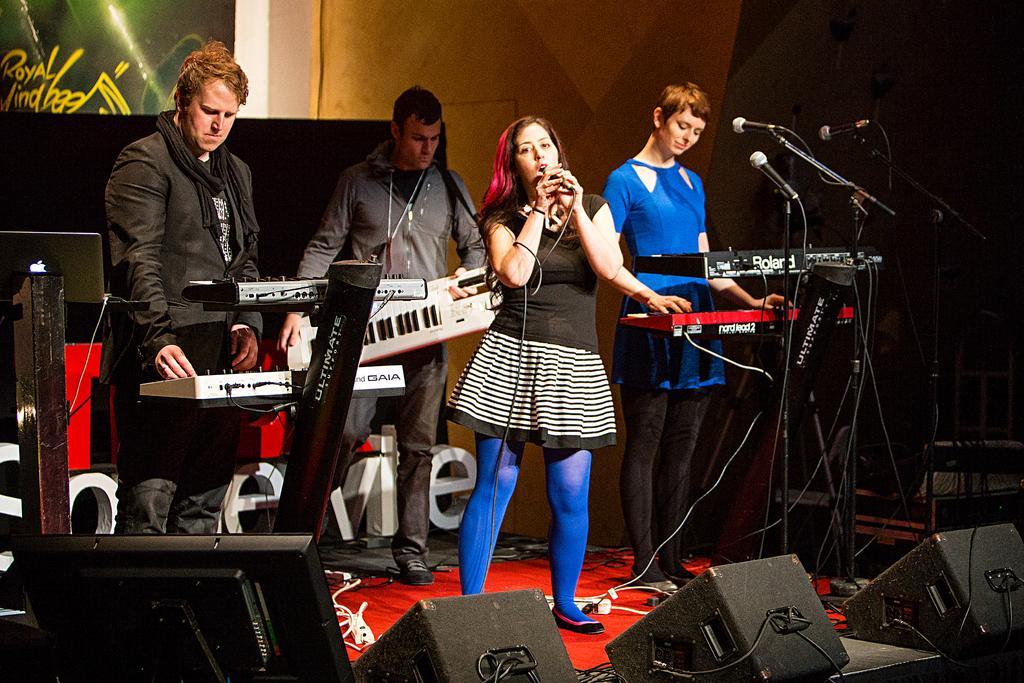In one or two sentences, can you explain what this image depicts? This woman is singing and holding mic. These persons are playing musical instruments. This is mic with holder. 